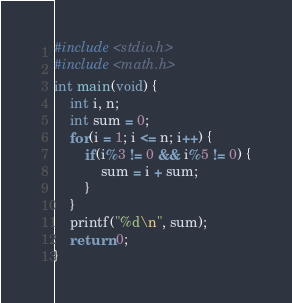<code> <loc_0><loc_0><loc_500><loc_500><_C_>#include <stdio.h>
#include <math.h>
int main(void) {
    int i, n;
    int sum = 0;
    for(i = 1; i <= n; i++) {
        if(i%3 != 0 && i%5 != 0) {
            sum = i + sum;
        }
    }
    printf("%d\n", sum);
    return 0;
}</code> 